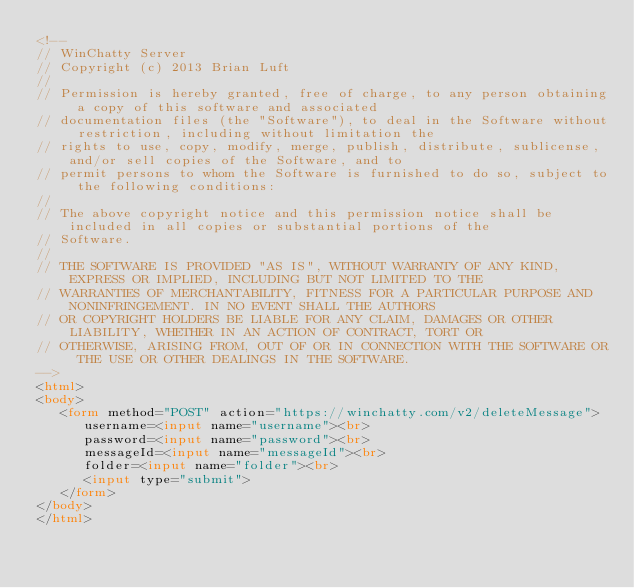<code> <loc_0><loc_0><loc_500><loc_500><_HTML_><!--
// WinChatty Server
// Copyright (c) 2013 Brian Luft
//
// Permission is hereby granted, free of charge, to any person obtaining a copy of this software and associated
// documentation files (the "Software"), to deal in the Software without restriction, including without limitation the
// rights to use, copy, modify, merge, publish, distribute, sublicense, and/or sell copies of the Software, and to
// permit persons to whom the Software is furnished to do so, subject to the following conditions:
//
// The above copyright notice and this permission notice shall be included in all copies or substantial portions of the
// Software.
//
// THE SOFTWARE IS PROVIDED "AS IS", WITHOUT WARRANTY OF ANY KIND, EXPRESS OR IMPLIED, INCLUDING BUT NOT LIMITED TO THE
// WARRANTIES OF MERCHANTABILITY, FITNESS FOR A PARTICULAR PURPOSE AND NONINFRINGEMENT. IN NO EVENT SHALL THE AUTHORS
// OR COPYRIGHT HOLDERS BE LIABLE FOR ANY CLAIM, DAMAGES OR OTHER LIABILITY, WHETHER IN AN ACTION OF CONTRACT, TORT OR
// OTHERWISE, ARISING FROM, OUT OF OR IN CONNECTION WITH THE SOFTWARE OR THE USE OR OTHER DEALINGS IN THE SOFTWARE.
-->
<html>
<body>
   <form method="POST" action="https://winchatty.com/v2/deleteMessage">
      username=<input name="username"><br>
      password=<input name="password"><br>
      messageId=<input name="messageId"><br>
      folder=<input name="folder"><br>
      <input type="submit">
   </form>
</body>
</html>
</code> 